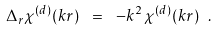<formula> <loc_0><loc_0><loc_500><loc_500>\Delta _ { r } \chi ^ { ( d ) } ( k r ) \ = \ - k ^ { 2 } \, \chi ^ { ( d ) } ( k r ) \ .</formula> 